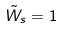Convert formula to latex. <formula><loc_0><loc_0><loc_500><loc_500>\tilde { W } _ { s } = 1</formula> 